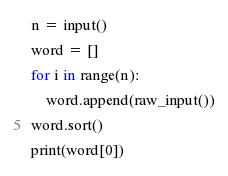<code> <loc_0><loc_0><loc_500><loc_500><_Python_>n = input()
word = []
for i in range(n):
    word.append(raw_input())
word.sort()
print(word[0])</code> 